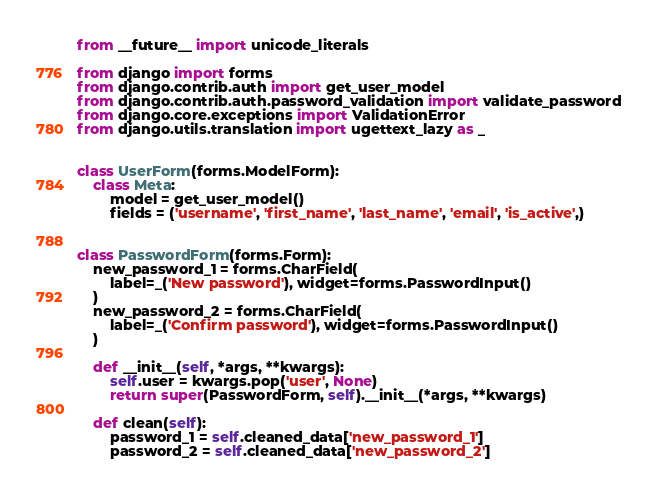<code> <loc_0><loc_0><loc_500><loc_500><_Python_>from __future__ import unicode_literals

from django import forms
from django.contrib.auth import get_user_model
from django.contrib.auth.password_validation import validate_password
from django.core.exceptions import ValidationError
from django.utils.translation import ugettext_lazy as _


class UserForm(forms.ModelForm):
    class Meta:
        model = get_user_model()
        fields = ('username', 'first_name', 'last_name', 'email', 'is_active',)


class PasswordForm(forms.Form):
    new_password_1 = forms.CharField(
        label=_('New password'), widget=forms.PasswordInput()
    )
    new_password_2 = forms.CharField(
        label=_('Confirm password'), widget=forms.PasswordInput()
    )

    def __init__(self, *args, **kwargs):
        self.user = kwargs.pop('user', None)
        return super(PasswordForm, self).__init__(*args, **kwargs)

    def clean(self):
        password_1 = self.cleaned_data['new_password_1']
        password_2 = self.cleaned_data['new_password_2']</code> 